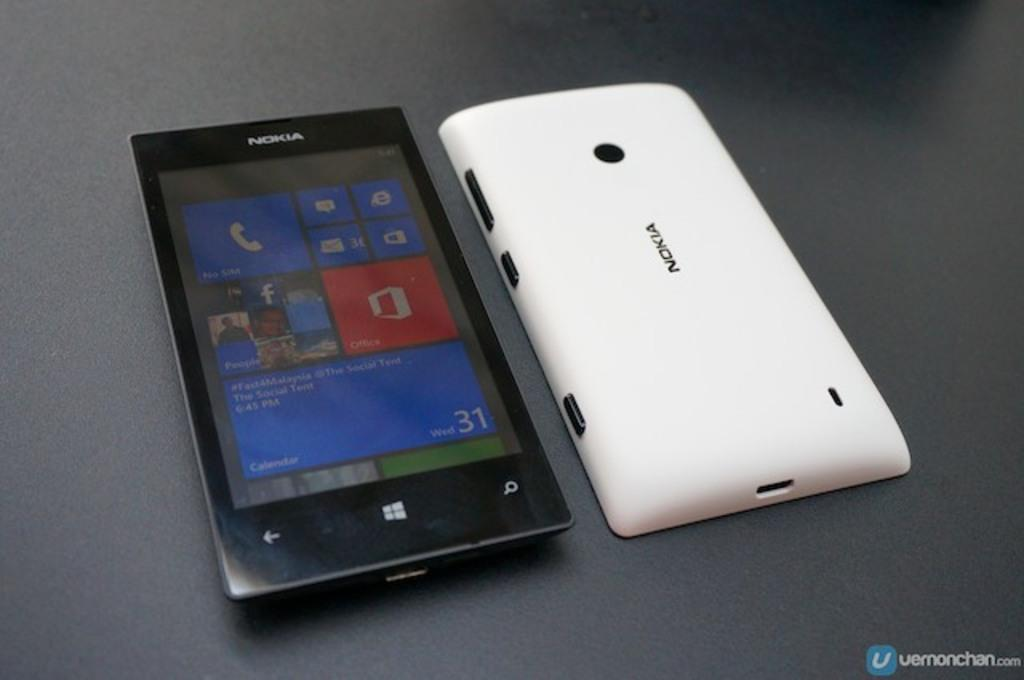<image>
Describe the image concisely. a noika cell phone with a fitted white plastic cover 